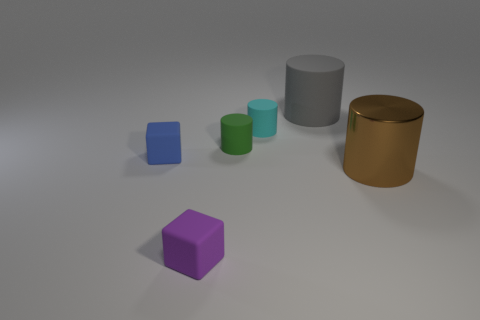What is the shape of the tiny blue matte thing?
Provide a short and direct response. Cube. What size is the gray matte object left of the large cylinder in front of the cyan cylinder?
Offer a terse response. Large. How big is the cylinder left of the small cyan matte object?
Offer a very short reply. Small. Is the number of large metal objects that are on the left side of the tiny cyan object less than the number of small purple matte objects in front of the gray matte thing?
Make the answer very short. Yes. The metallic cylinder is what color?
Give a very brief answer. Brown. There is a tiny rubber object that is in front of the tiny block to the left of the small purple matte block to the right of the blue rubber object; what shape is it?
Your answer should be very brief. Cube. There is a big object in front of the big matte thing; what is it made of?
Make the answer very short. Metal. There is a object right of the big thing that is behind the rubber thing that is on the left side of the purple rubber block; what size is it?
Keep it short and to the point. Large. There is a purple rubber block; is its size the same as the rubber block that is behind the large brown cylinder?
Your response must be concise. Yes. There is a big cylinder that is in front of the large gray matte cylinder; what is its color?
Your answer should be very brief. Brown. 